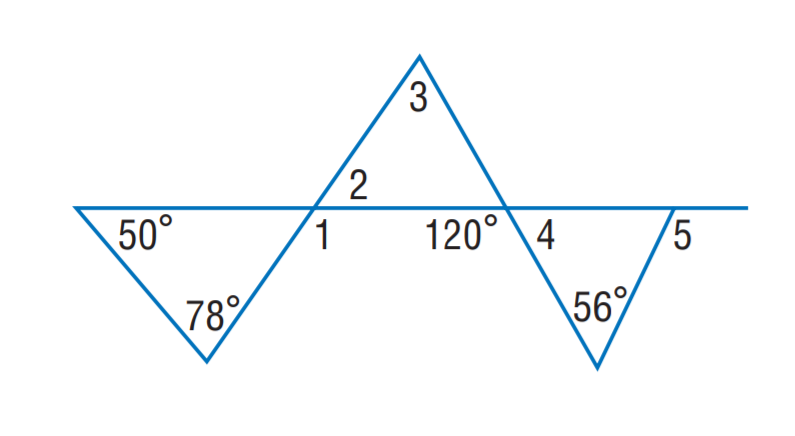Answer the mathemtical geometry problem and directly provide the correct option letter.
Question: Find m \angle 1.
Choices: A: 78 B: 115 C: 120 D: 128 D 